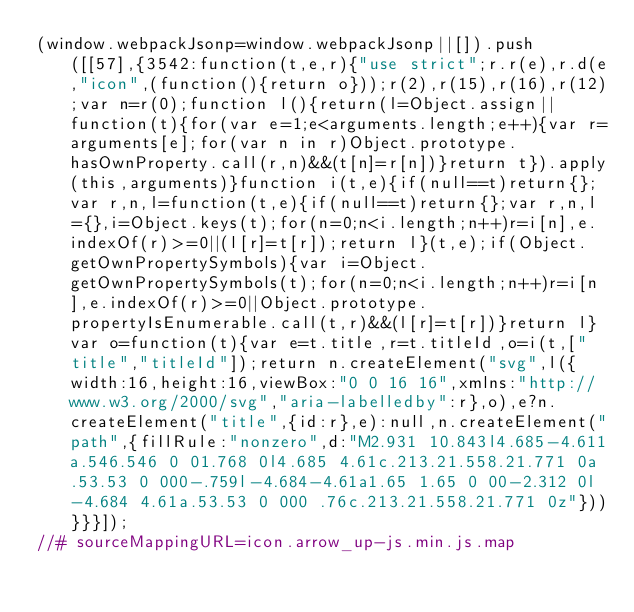Convert code to text. <code><loc_0><loc_0><loc_500><loc_500><_JavaScript_>(window.webpackJsonp=window.webpackJsonp||[]).push([[57],{3542:function(t,e,r){"use strict";r.r(e),r.d(e,"icon",(function(){return o}));r(2),r(15),r(16),r(12);var n=r(0);function l(){return(l=Object.assign||function(t){for(var e=1;e<arguments.length;e++){var r=arguments[e];for(var n in r)Object.prototype.hasOwnProperty.call(r,n)&&(t[n]=r[n])}return t}).apply(this,arguments)}function i(t,e){if(null==t)return{};var r,n,l=function(t,e){if(null==t)return{};var r,n,l={},i=Object.keys(t);for(n=0;n<i.length;n++)r=i[n],e.indexOf(r)>=0||(l[r]=t[r]);return l}(t,e);if(Object.getOwnPropertySymbols){var i=Object.getOwnPropertySymbols(t);for(n=0;n<i.length;n++)r=i[n],e.indexOf(r)>=0||Object.prototype.propertyIsEnumerable.call(t,r)&&(l[r]=t[r])}return l}var o=function(t){var e=t.title,r=t.titleId,o=i(t,["title","titleId"]);return n.createElement("svg",l({width:16,height:16,viewBox:"0 0 16 16",xmlns:"http://www.w3.org/2000/svg","aria-labelledby":r},o),e?n.createElement("title",{id:r},e):null,n.createElement("path",{fillRule:"nonzero",d:"M2.931 10.843l4.685-4.611a.546.546 0 01.768 0l4.685 4.61c.213.21.558.21.771 0a.53.53 0 000-.759l-4.684-4.61a1.65 1.65 0 00-2.312 0l-4.684 4.61a.53.53 0 000 .76c.213.21.558.21.771 0z"}))}}}]);
//# sourceMappingURL=icon.arrow_up-js.min.js.map</code> 